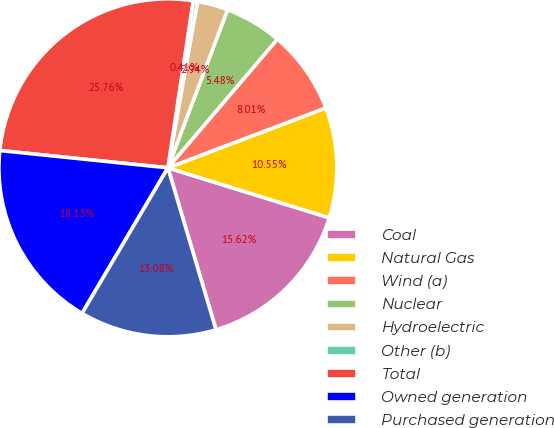Convert chart. <chart><loc_0><loc_0><loc_500><loc_500><pie_chart><fcel>Coal<fcel>Natural Gas<fcel>Wind (a)<fcel>Nuclear<fcel>Hydroelectric<fcel>Other (b)<fcel>Total<fcel>Owned generation<fcel>Purchased generation<nl><fcel>15.62%<fcel>10.55%<fcel>8.01%<fcel>5.48%<fcel>2.94%<fcel>0.41%<fcel>25.76%<fcel>18.15%<fcel>13.08%<nl></chart> 